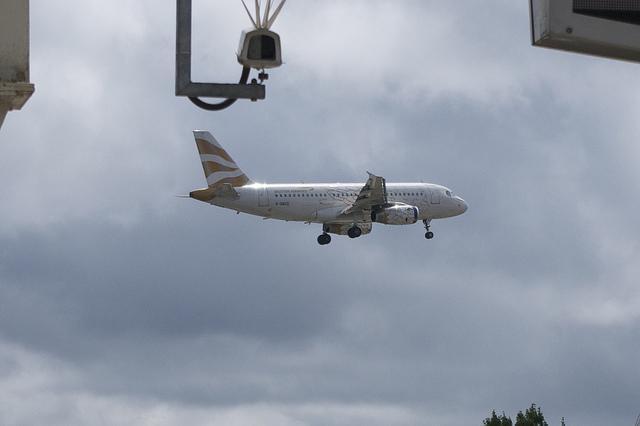How many giraffes are in the photo?
Give a very brief answer. 0. 